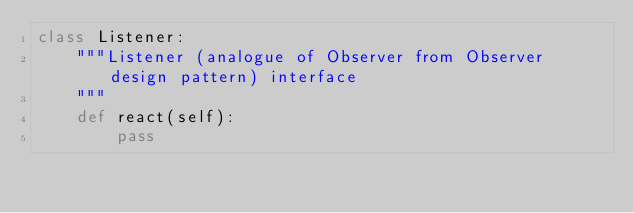Convert code to text. <code><loc_0><loc_0><loc_500><loc_500><_Python_>class Listener:
    """Listener (analogue of Observer from Observer design pattern) interface
    """
    def react(self):
        pass
</code> 